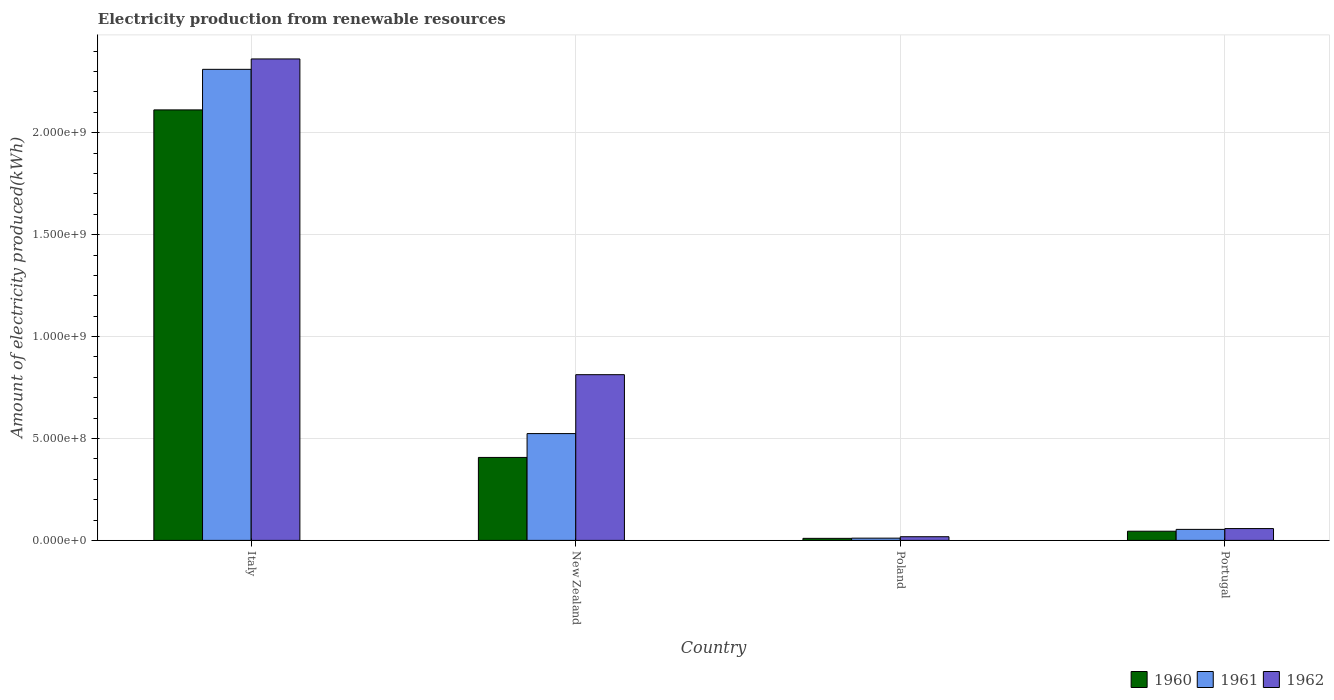How many groups of bars are there?
Keep it short and to the point. 4. How many bars are there on the 4th tick from the left?
Your answer should be very brief. 3. What is the label of the 2nd group of bars from the left?
Provide a short and direct response. New Zealand. In how many cases, is the number of bars for a given country not equal to the number of legend labels?
Offer a terse response. 0. What is the amount of electricity produced in 1961 in Portugal?
Offer a terse response. 5.40e+07. Across all countries, what is the maximum amount of electricity produced in 1960?
Your answer should be very brief. 2.11e+09. In which country was the amount of electricity produced in 1960 maximum?
Keep it short and to the point. Italy. What is the total amount of electricity produced in 1961 in the graph?
Offer a terse response. 2.90e+09. What is the difference between the amount of electricity produced in 1960 in Italy and that in New Zealand?
Offer a terse response. 1.70e+09. What is the difference between the amount of electricity produced in 1961 in Portugal and the amount of electricity produced in 1960 in New Zealand?
Keep it short and to the point. -3.53e+08. What is the average amount of electricity produced in 1961 per country?
Provide a succinct answer. 7.25e+08. What is the difference between the amount of electricity produced of/in 1960 and amount of electricity produced of/in 1961 in Portugal?
Your answer should be very brief. -9.00e+06. What is the ratio of the amount of electricity produced in 1962 in Italy to that in New Zealand?
Provide a short and direct response. 2.91. What is the difference between the highest and the second highest amount of electricity produced in 1960?
Keep it short and to the point. 2.07e+09. What is the difference between the highest and the lowest amount of electricity produced in 1961?
Your answer should be compact. 2.30e+09. In how many countries, is the amount of electricity produced in 1962 greater than the average amount of electricity produced in 1962 taken over all countries?
Offer a very short reply. 2. Is the sum of the amount of electricity produced in 1961 in Italy and Poland greater than the maximum amount of electricity produced in 1962 across all countries?
Your response must be concise. No. What does the 3rd bar from the right in Portugal represents?
Your response must be concise. 1960. Is it the case that in every country, the sum of the amount of electricity produced in 1961 and amount of electricity produced in 1962 is greater than the amount of electricity produced in 1960?
Your answer should be compact. Yes. Are all the bars in the graph horizontal?
Your answer should be very brief. No. How many countries are there in the graph?
Make the answer very short. 4. Are the values on the major ticks of Y-axis written in scientific E-notation?
Your answer should be compact. Yes. Does the graph contain any zero values?
Your answer should be compact. No. Does the graph contain grids?
Keep it short and to the point. Yes. Where does the legend appear in the graph?
Provide a short and direct response. Bottom right. How are the legend labels stacked?
Your response must be concise. Horizontal. What is the title of the graph?
Offer a very short reply. Electricity production from renewable resources. What is the label or title of the Y-axis?
Give a very brief answer. Amount of electricity produced(kWh). What is the Amount of electricity produced(kWh) of 1960 in Italy?
Ensure brevity in your answer.  2.11e+09. What is the Amount of electricity produced(kWh) of 1961 in Italy?
Offer a very short reply. 2.31e+09. What is the Amount of electricity produced(kWh) of 1962 in Italy?
Offer a very short reply. 2.36e+09. What is the Amount of electricity produced(kWh) of 1960 in New Zealand?
Provide a succinct answer. 4.07e+08. What is the Amount of electricity produced(kWh) of 1961 in New Zealand?
Give a very brief answer. 5.24e+08. What is the Amount of electricity produced(kWh) of 1962 in New Zealand?
Ensure brevity in your answer.  8.13e+08. What is the Amount of electricity produced(kWh) in 1960 in Poland?
Your answer should be compact. 1.00e+07. What is the Amount of electricity produced(kWh) of 1961 in Poland?
Provide a short and direct response. 1.10e+07. What is the Amount of electricity produced(kWh) in 1962 in Poland?
Your answer should be compact. 1.80e+07. What is the Amount of electricity produced(kWh) in 1960 in Portugal?
Your answer should be compact. 4.50e+07. What is the Amount of electricity produced(kWh) of 1961 in Portugal?
Offer a very short reply. 5.40e+07. What is the Amount of electricity produced(kWh) in 1962 in Portugal?
Keep it short and to the point. 5.80e+07. Across all countries, what is the maximum Amount of electricity produced(kWh) of 1960?
Make the answer very short. 2.11e+09. Across all countries, what is the maximum Amount of electricity produced(kWh) in 1961?
Keep it short and to the point. 2.31e+09. Across all countries, what is the maximum Amount of electricity produced(kWh) in 1962?
Your answer should be very brief. 2.36e+09. Across all countries, what is the minimum Amount of electricity produced(kWh) of 1961?
Offer a very short reply. 1.10e+07. Across all countries, what is the minimum Amount of electricity produced(kWh) in 1962?
Offer a terse response. 1.80e+07. What is the total Amount of electricity produced(kWh) in 1960 in the graph?
Your answer should be compact. 2.57e+09. What is the total Amount of electricity produced(kWh) of 1961 in the graph?
Your response must be concise. 2.90e+09. What is the total Amount of electricity produced(kWh) of 1962 in the graph?
Ensure brevity in your answer.  3.25e+09. What is the difference between the Amount of electricity produced(kWh) of 1960 in Italy and that in New Zealand?
Give a very brief answer. 1.70e+09. What is the difference between the Amount of electricity produced(kWh) in 1961 in Italy and that in New Zealand?
Offer a very short reply. 1.79e+09. What is the difference between the Amount of electricity produced(kWh) of 1962 in Italy and that in New Zealand?
Offer a terse response. 1.55e+09. What is the difference between the Amount of electricity produced(kWh) in 1960 in Italy and that in Poland?
Make the answer very short. 2.10e+09. What is the difference between the Amount of electricity produced(kWh) in 1961 in Italy and that in Poland?
Keep it short and to the point. 2.30e+09. What is the difference between the Amount of electricity produced(kWh) in 1962 in Italy and that in Poland?
Offer a terse response. 2.34e+09. What is the difference between the Amount of electricity produced(kWh) of 1960 in Italy and that in Portugal?
Provide a short and direct response. 2.07e+09. What is the difference between the Amount of electricity produced(kWh) of 1961 in Italy and that in Portugal?
Your response must be concise. 2.26e+09. What is the difference between the Amount of electricity produced(kWh) in 1962 in Italy and that in Portugal?
Your response must be concise. 2.30e+09. What is the difference between the Amount of electricity produced(kWh) in 1960 in New Zealand and that in Poland?
Provide a succinct answer. 3.97e+08. What is the difference between the Amount of electricity produced(kWh) of 1961 in New Zealand and that in Poland?
Make the answer very short. 5.13e+08. What is the difference between the Amount of electricity produced(kWh) of 1962 in New Zealand and that in Poland?
Your answer should be very brief. 7.95e+08. What is the difference between the Amount of electricity produced(kWh) of 1960 in New Zealand and that in Portugal?
Offer a terse response. 3.62e+08. What is the difference between the Amount of electricity produced(kWh) of 1961 in New Zealand and that in Portugal?
Keep it short and to the point. 4.70e+08. What is the difference between the Amount of electricity produced(kWh) of 1962 in New Zealand and that in Portugal?
Keep it short and to the point. 7.55e+08. What is the difference between the Amount of electricity produced(kWh) of 1960 in Poland and that in Portugal?
Your answer should be very brief. -3.50e+07. What is the difference between the Amount of electricity produced(kWh) in 1961 in Poland and that in Portugal?
Make the answer very short. -4.30e+07. What is the difference between the Amount of electricity produced(kWh) in 1962 in Poland and that in Portugal?
Keep it short and to the point. -4.00e+07. What is the difference between the Amount of electricity produced(kWh) in 1960 in Italy and the Amount of electricity produced(kWh) in 1961 in New Zealand?
Your answer should be very brief. 1.59e+09. What is the difference between the Amount of electricity produced(kWh) of 1960 in Italy and the Amount of electricity produced(kWh) of 1962 in New Zealand?
Ensure brevity in your answer.  1.30e+09. What is the difference between the Amount of electricity produced(kWh) in 1961 in Italy and the Amount of electricity produced(kWh) in 1962 in New Zealand?
Your answer should be compact. 1.50e+09. What is the difference between the Amount of electricity produced(kWh) in 1960 in Italy and the Amount of electricity produced(kWh) in 1961 in Poland?
Ensure brevity in your answer.  2.10e+09. What is the difference between the Amount of electricity produced(kWh) of 1960 in Italy and the Amount of electricity produced(kWh) of 1962 in Poland?
Offer a terse response. 2.09e+09. What is the difference between the Amount of electricity produced(kWh) of 1961 in Italy and the Amount of electricity produced(kWh) of 1962 in Poland?
Give a very brief answer. 2.29e+09. What is the difference between the Amount of electricity produced(kWh) of 1960 in Italy and the Amount of electricity produced(kWh) of 1961 in Portugal?
Give a very brief answer. 2.06e+09. What is the difference between the Amount of electricity produced(kWh) of 1960 in Italy and the Amount of electricity produced(kWh) of 1962 in Portugal?
Keep it short and to the point. 2.05e+09. What is the difference between the Amount of electricity produced(kWh) of 1961 in Italy and the Amount of electricity produced(kWh) of 1962 in Portugal?
Offer a terse response. 2.25e+09. What is the difference between the Amount of electricity produced(kWh) in 1960 in New Zealand and the Amount of electricity produced(kWh) in 1961 in Poland?
Offer a very short reply. 3.96e+08. What is the difference between the Amount of electricity produced(kWh) in 1960 in New Zealand and the Amount of electricity produced(kWh) in 1962 in Poland?
Ensure brevity in your answer.  3.89e+08. What is the difference between the Amount of electricity produced(kWh) in 1961 in New Zealand and the Amount of electricity produced(kWh) in 1962 in Poland?
Your answer should be very brief. 5.06e+08. What is the difference between the Amount of electricity produced(kWh) of 1960 in New Zealand and the Amount of electricity produced(kWh) of 1961 in Portugal?
Keep it short and to the point. 3.53e+08. What is the difference between the Amount of electricity produced(kWh) of 1960 in New Zealand and the Amount of electricity produced(kWh) of 1962 in Portugal?
Your answer should be compact. 3.49e+08. What is the difference between the Amount of electricity produced(kWh) in 1961 in New Zealand and the Amount of electricity produced(kWh) in 1962 in Portugal?
Make the answer very short. 4.66e+08. What is the difference between the Amount of electricity produced(kWh) in 1960 in Poland and the Amount of electricity produced(kWh) in 1961 in Portugal?
Make the answer very short. -4.40e+07. What is the difference between the Amount of electricity produced(kWh) in 1960 in Poland and the Amount of electricity produced(kWh) in 1962 in Portugal?
Your response must be concise. -4.80e+07. What is the difference between the Amount of electricity produced(kWh) in 1961 in Poland and the Amount of electricity produced(kWh) in 1962 in Portugal?
Keep it short and to the point. -4.70e+07. What is the average Amount of electricity produced(kWh) in 1960 per country?
Ensure brevity in your answer.  6.44e+08. What is the average Amount of electricity produced(kWh) of 1961 per country?
Your answer should be very brief. 7.25e+08. What is the average Amount of electricity produced(kWh) of 1962 per country?
Offer a very short reply. 8.13e+08. What is the difference between the Amount of electricity produced(kWh) of 1960 and Amount of electricity produced(kWh) of 1961 in Italy?
Offer a very short reply. -1.99e+08. What is the difference between the Amount of electricity produced(kWh) of 1960 and Amount of electricity produced(kWh) of 1962 in Italy?
Keep it short and to the point. -2.50e+08. What is the difference between the Amount of electricity produced(kWh) in 1961 and Amount of electricity produced(kWh) in 1962 in Italy?
Your response must be concise. -5.10e+07. What is the difference between the Amount of electricity produced(kWh) of 1960 and Amount of electricity produced(kWh) of 1961 in New Zealand?
Your answer should be compact. -1.17e+08. What is the difference between the Amount of electricity produced(kWh) in 1960 and Amount of electricity produced(kWh) in 1962 in New Zealand?
Keep it short and to the point. -4.06e+08. What is the difference between the Amount of electricity produced(kWh) in 1961 and Amount of electricity produced(kWh) in 1962 in New Zealand?
Provide a succinct answer. -2.89e+08. What is the difference between the Amount of electricity produced(kWh) in 1960 and Amount of electricity produced(kWh) in 1961 in Poland?
Offer a terse response. -1.00e+06. What is the difference between the Amount of electricity produced(kWh) of 1960 and Amount of electricity produced(kWh) of 1962 in Poland?
Ensure brevity in your answer.  -8.00e+06. What is the difference between the Amount of electricity produced(kWh) in 1961 and Amount of electricity produced(kWh) in 1962 in Poland?
Keep it short and to the point. -7.00e+06. What is the difference between the Amount of electricity produced(kWh) of 1960 and Amount of electricity produced(kWh) of 1961 in Portugal?
Keep it short and to the point. -9.00e+06. What is the difference between the Amount of electricity produced(kWh) of 1960 and Amount of electricity produced(kWh) of 1962 in Portugal?
Make the answer very short. -1.30e+07. What is the ratio of the Amount of electricity produced(kWh) of 1960 in Italy to that in New Zealand?
Ensure brevity in your answer.  5.19. What is the ratio of the Amount of electricity produced(kWh) in 1961 in Italy to that in New Zealand?
Offer a terse response. 4.41. What is the ratio of the Amount of electricity produced(kWh) of 1962 in Italy to that in New Zealand?
Keep it short and to the point. 2.91. What is the ratio of the Amount of electricity produced(kWh) of 1960 in Italy to that in Poland?
Offer a terse response. 211.2. What is the ratio of the Amount of electricity produced(kWh) of 1961 in Italy to that in Poland?
Offer a very short reply. 210.09. What is the ratio of the Amount of electricity produced(kWh) in 1962 in Italy to that in Poland?
Give a very brief answer. 131.22. What is the ratio of the Amount of electricity produced(kWh) in 1960 in Italy to that in Portugal?
Ensure brevity in your answer.  46.93. What is the ratio of the Amount of electricity produced(kWh) in 1961 in Italy to that in Portugal?
Ensure brevity in your answer.  42.8. What is the ratio of the Amount of electricity produced(kWh) of 1962 in Italy to that in Portugal?
Give a very brief answer. 40.72. What is the ratio of the Amount of electricity produced(kWh) of 1960 in New Zealand to that in Poland?
Keep it short and to the point. 40.7. What is the ratio of the Amount of electricity produced(kWh) of 1961 in New Zealand to that in Poland?
Your answer should be compact. 47.64. What is the ratio of the Amount of electricity produced(kWh) in 1962 in New Zealand to that in Poland?
Offer a very short reply. 45.17. What is the ratio of the Amount of electricity produced(kWh) in 1960 in New Zealand to that in Portugal?
Keep it short and to the point. 9.04. What is the ratio of the Amount of electricity produced(kWh) in 1961 in New Zealand to that in Portugal?
Provide a short and direct response. 9.7. What is the ratio of the Amount of electricity produced(kWh) of 1962 in New Zealand to that in Portugal?
Your response must be concise. 14.02. What is the ratio of the Amount of electricity produced(kWh) of 1960 in Poland to that in Portugal?
Keep it short and to the point. 0.22. What is the ratio of the Amount of electricity produced(kWh) of 1961 in Poland to that in Portugal?
Provide a succinct answer. 0.2. What is the ratio of the Amount of electricity produced(kWh) in 1962 in Poland to that in Portugal?
Offer a terse response. 0.31. What is the difference between the highest and the second highest Amount of electricity produced(kWh) in 1960?
Give a very brief answer. 1.70e+09. What is the difference between the highest and the second highest Amount of electricity produced(kWh) in 1961?
Give a very brief answer. 1.79e+09. What is the difference between the highest and the second highest Amount of electricity produced(kWh) in 1962?
Provide a short and direct response. 1.55e+09. What is the difference between the highest and the lowest Amount of electricity produced(kWh) in 1960?
Your answer should be very brief. 2.10e+09. What is the difference between the highest and the lowest Amount of electricity produced(kWh) in 1961?
Give a very brief answer. 2.30e+09. What is the difference between the highest and the lowest Amount of electricity produced(kWh) in 1962?
Keep it short and to the point. 2.34e+09. 